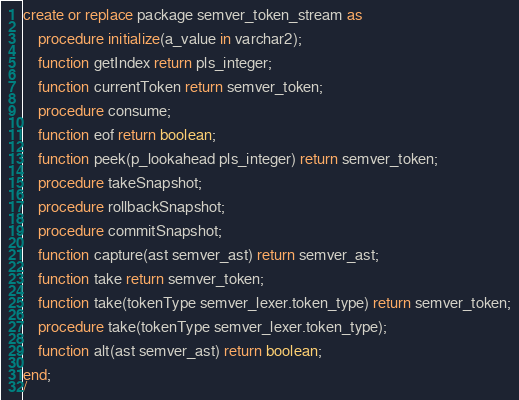<code> <loc_0><loc_0><loc_500><loc_500><_SQL_>create or replace package semver_token_stream as

    procedure initialize(a_value in varchar2);

    function getIndex return pls_integer;

    function currentToken return semver_token;

    procedure consume;

    function eof return boolean;

    function peek(p_lookahead pls_integer) return semver_token;

    procedure takeSnapshot;

    procedure rollbackSnapshot;

    procedure commitSnapshot;

    function capture(ast semver_ast) return semver_ast;

    function take return semver_token;

    function take(tokenType semver_lexer.token_type) return semver_token;

    procedure take(tokenType semver_lexer.token_type);

    function alt(ast semver_ast) return boolean;

end;
/
</code> 